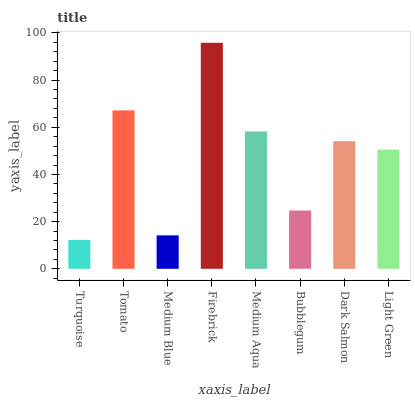Is Turquoise the minimum?
Answer yes or no. Yes. Is Firebrick the maximum?
Answer yes or no. Yes. Is Tomato the minimum?
Answer yes or no. No. Is Tomato the maximum?
Answer yes or no. No. Is Tomato greater than Turquoise?
Answer yes or no. Yes. Is Turquoise less than Tomato?
Answer yes or no. Yes. Is Turquoise greater than Tomato?
Answer yes or no. No. Is Tomato less than Turquoise?
Answer yes or no. No. Is Dark Salmon the high median?
Answer yes or no. Yes. Is Light Green the low median?
Answer yes or no. Yes. Is Medium Blue the high median?
Answer yes or no. No. Is Turquoise the low median?
Answer yes or no. No. 